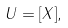<formula> <loc_0><loc_0><loc_500><loc_500>U = [ X ] ,</formula> 